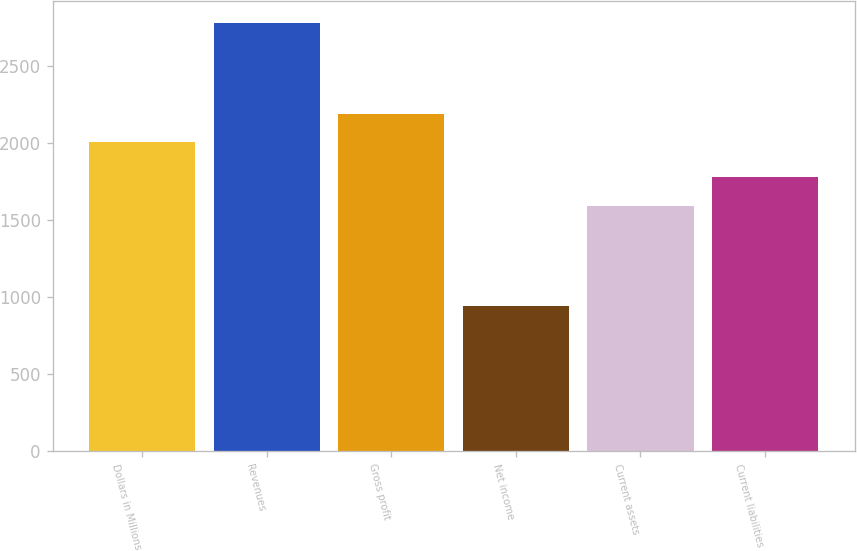<chart> <loc_0><loc_0><loc_500><loc_500><bar_chart><fcel>Dollars in Millions<fcel>Revenues<fcel>Gross profit<fcel>Net income<fcel>Current assets<fcel>Current liabilities<nl><fcel>2006<fcel>2785<fcel>2190.3<fcel>942<fcel>1595<fcel>1779.3<nl></chart> 